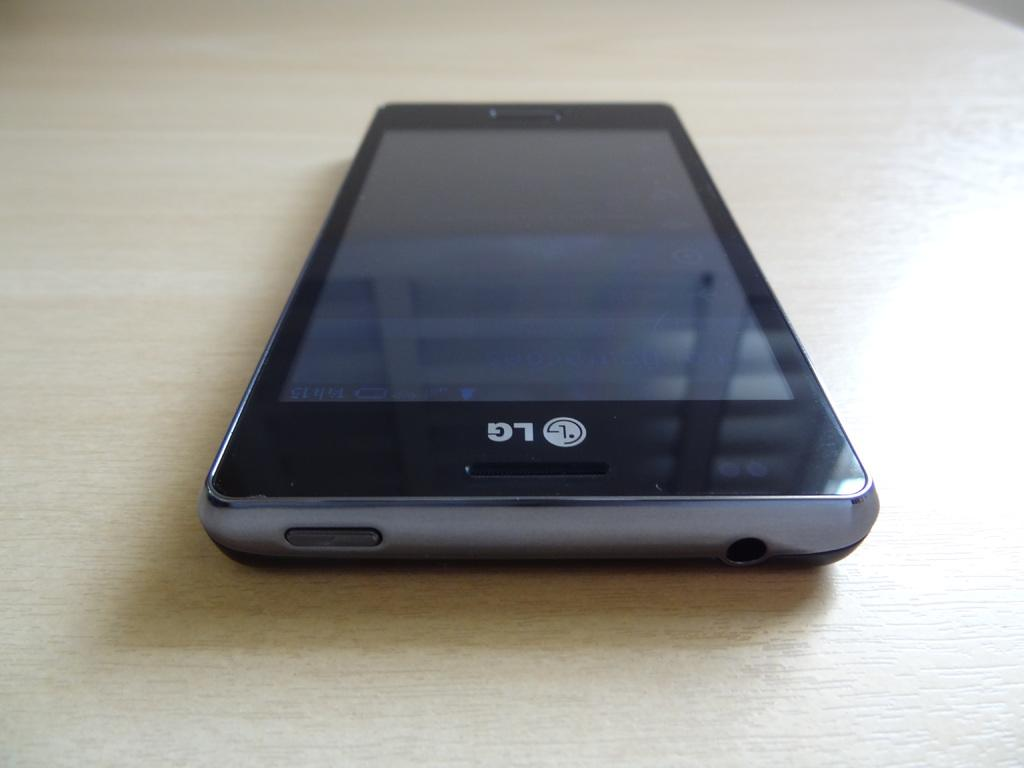Provide a one-sentence caption for the provided image. An LG phone is sitting on a table. 